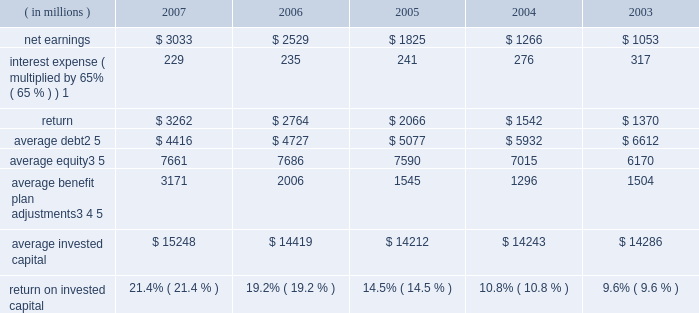( c ) includes the effects of items not considered in the assessment of the operating performance of our business segments which increased operating profit by $ 230 million , $ 150 million after tax ( $ 0.34 per share ) .
Also includes expenses of $ 16 million , $ 11 million after tax ( $ 0.03 per share ) for a debt exchange , and a reduction in income tax expense of $ 62 million ( $ 0.14 per share ) resulting from a tax benefit related to claims we filed for additional extraterritorial income exclusion ( eti ) tax benefits .
On a combined basis , these items increased earnings by $ 201 million after tax ( $ 0.45 per share ) .
( d ) includes the effects of items not considered in the assessment of the operating performance of our business segments which , on a combined basis , increased operating profit by $ 173 million , $ 113 million after tax ( $ 0.25 per share ) .
( e ) includes the effects of items not considered in the assessment of the operating performance of our business segments which decreased operating profit by $ 61 million , $ 54 million after tax ( $ 0.12 per share ) .
Also includes a charge of $ 154 million , $ 100 million after tax ( $ 0.22 per share ) for the early repayment of debt , and a reduction in income tax expense resulting from the closure of an internal revenue service examination of $ 144 million ( $ 0.32 per share ) .
On a combined basis , these items reduced earnings by $ 10 million after tax ( $ 0.02 per share ) .
( f ) includes the effects of items not considered in the assessment of the operating performance of our business segments which , on a combined basis , decreased operating profit by $ 7 million , $ 6 million after tax ( $ 0.01 per share ) .
Also includes a charge of $ 146 million , $ 96 million after tax ( $ 0.21 per share ) for the early repayment of debt .
( g ) we define return on invested capital ( roic ) as net earnings plus after-tax interest expense divided by average invested capital ( stockholders 2019 equity plus debt ) , after adjusting stockholders 2019 equity by adding back adjustments related to postretirement benefit plans .
We believe that reporting roic provides investors with greater visibility into how effectively we use the capital invested in our operations .
We use roic to evaluate multi-year investment decisions and as a long-term performance measure , and also use it as a factor in evaluating management performance under certain of our incentive compensation plans .
Roic is not a measure of financial performance under generally accepted accounting principles , and may not be defined and calculated by other companies in the same manner .
Roic should not be considered in isolation or as an alternative to net earnings as an indicator of performance .
We calculate roic as follows : ( in millions ) 2007 2006 2005 2004 2003 .
1 represents after-tax interest expense utilizing the federal statutory rate of 35% ( 35 % ) .
2 debt consists of long-term debt , including current maturities of long-term debt , and short-term borrowings ( if any ) .
3 equity includes non-cash adjustments , primarily for unrecognized benefit plan actuarial losses and prior service costs in 2007 and 2006 , the adjustment for the adoption of fas 158 in 2006 , and the additional minimum pension liability in years prior to 2007 .
4 average benefit plan adjustments reflect the cumulative value of entries identified in our statement of stockholders equity under the captions 201cpostretirement benefit plans , 201d 201cadjustment for adoption of fas 158 201d and 201cminimum pension liability . 201d the total of annual benefit plan adjustments to equity were : 2007 = $ 1706 million ; 2006 = ( $ 1883 ) million ; 2005 = ( $ 105 ) million ; 2004 = ( $ 285 ) million ; 2003 = $ 331 million ; 2002 = ( $ 1537 million ) ; and 2001 = ( $ 33 million ) .
As these entries are recorded in the fourth quarter , the value added back to our average equity in a given year is the cumulative impact of all prior year entries plus 20% ( 20 % ) of the current year entry value .
5 yearly averages are calculated using balances at the start of the year and at the end of each quarter. .
What was the percentage growth in net earnings from 2003 to 2004? 
Computations: ((1266 - 1053) / 1053)
Answer: 0.20228. 